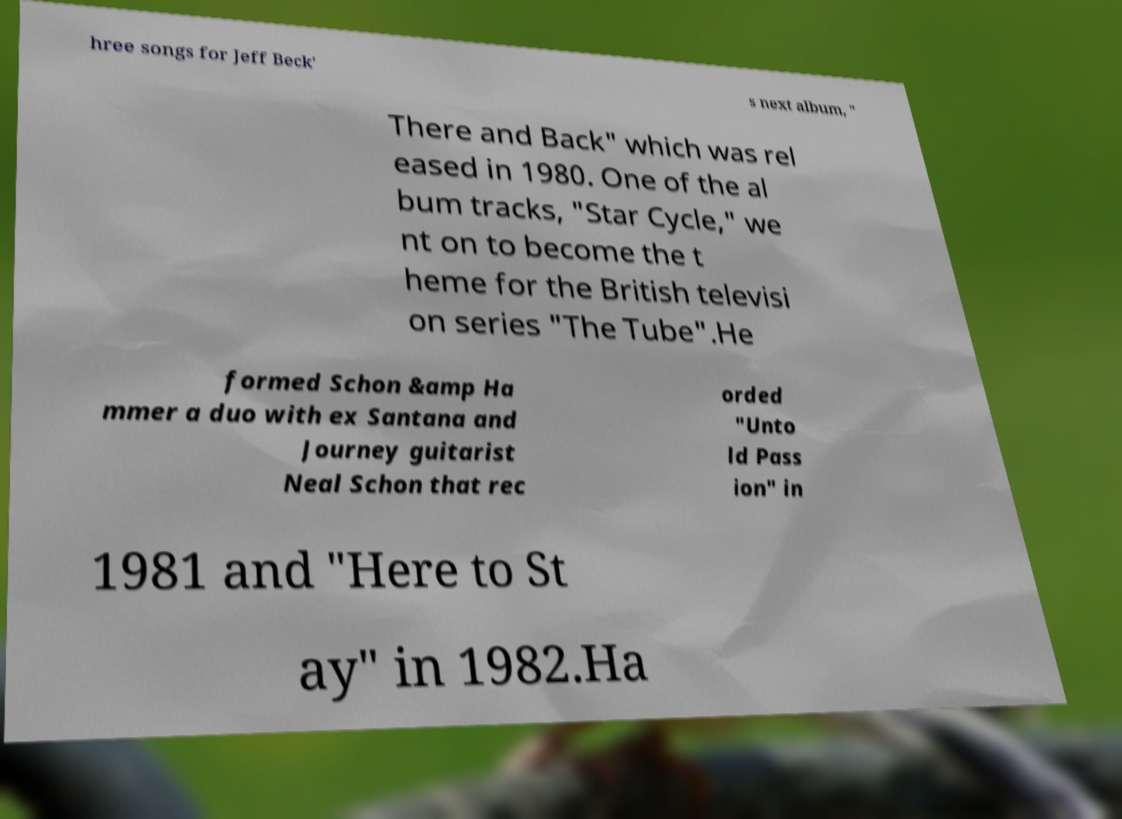Could you extract and type out the text from this image? hree songs for Jeff Beck' s next album, " There and Back" which was rel eased in 1980. One of the al bum tracks, "Star Cycle," we nt on to become the t heme for the British televisi on series "The Tube".He formed Schon &amp Ha mmer a duo with ex Santana and Journey guitarist Neal Schon that rec orded "Unto ld Pass ion" in 1981 and "Here to St ay" in 1982.Ha 